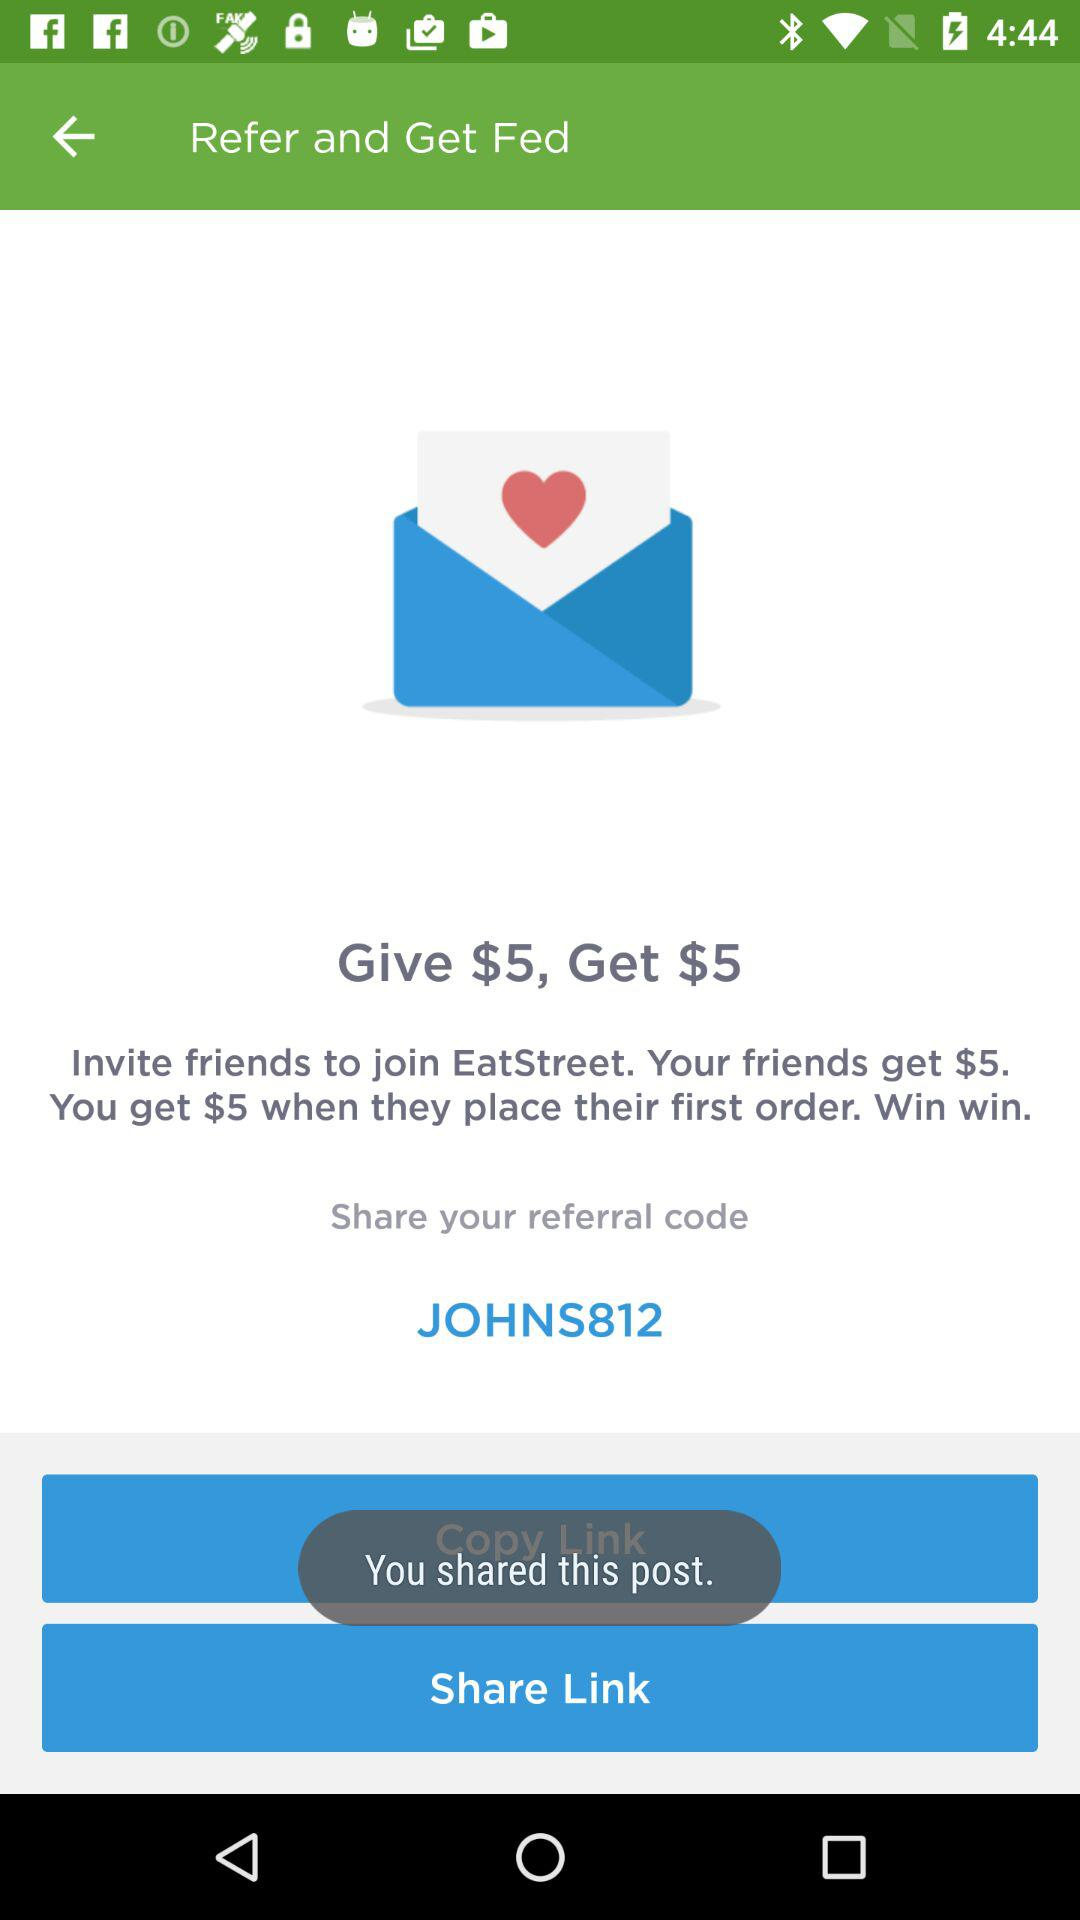What is the currency for the amount? The currency for the amount is the dollar($). 